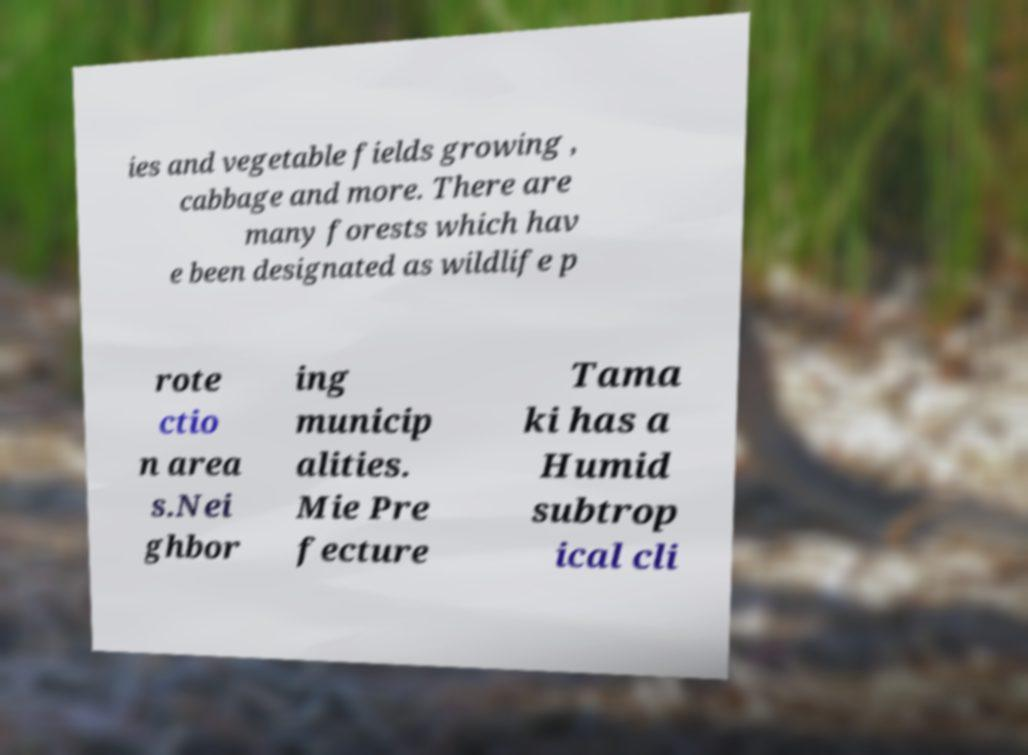What messages or text are displayed in this image? I need them in a readable, typed format. ies and vegetable fields growing , cabbage and more. There are many forests which hav e been designated as wildlife p rote ctio n area s.Nei ghbor ing municip alities. Mie Pre fecture Tama ki has a Humid subtrop ical cli 